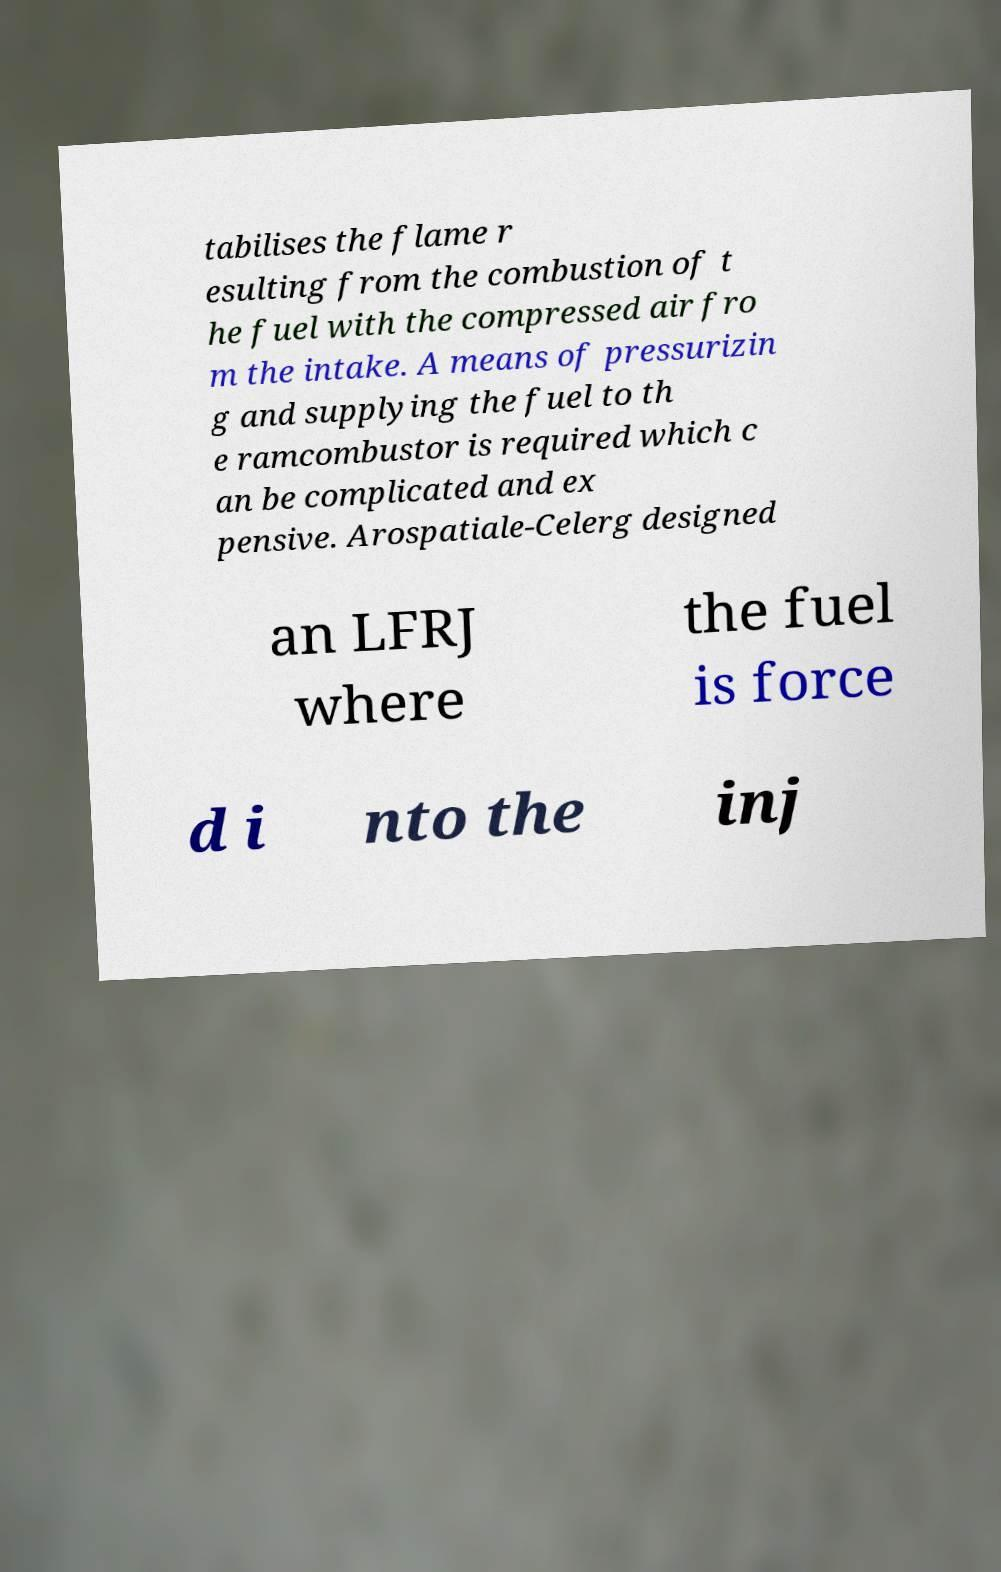Please read and relay the text visible in this image. What does it say? tabilises the flame r esulting from the combustion of t he fuel with the compressed air fro m the intake. A means of pressurizin g and supplying the fuel to th e ramcombustor is required which c an be complicated and ex pensive. Arospatiale-Celerg designed an LFRJ where the fuel is force d i nto the inj 